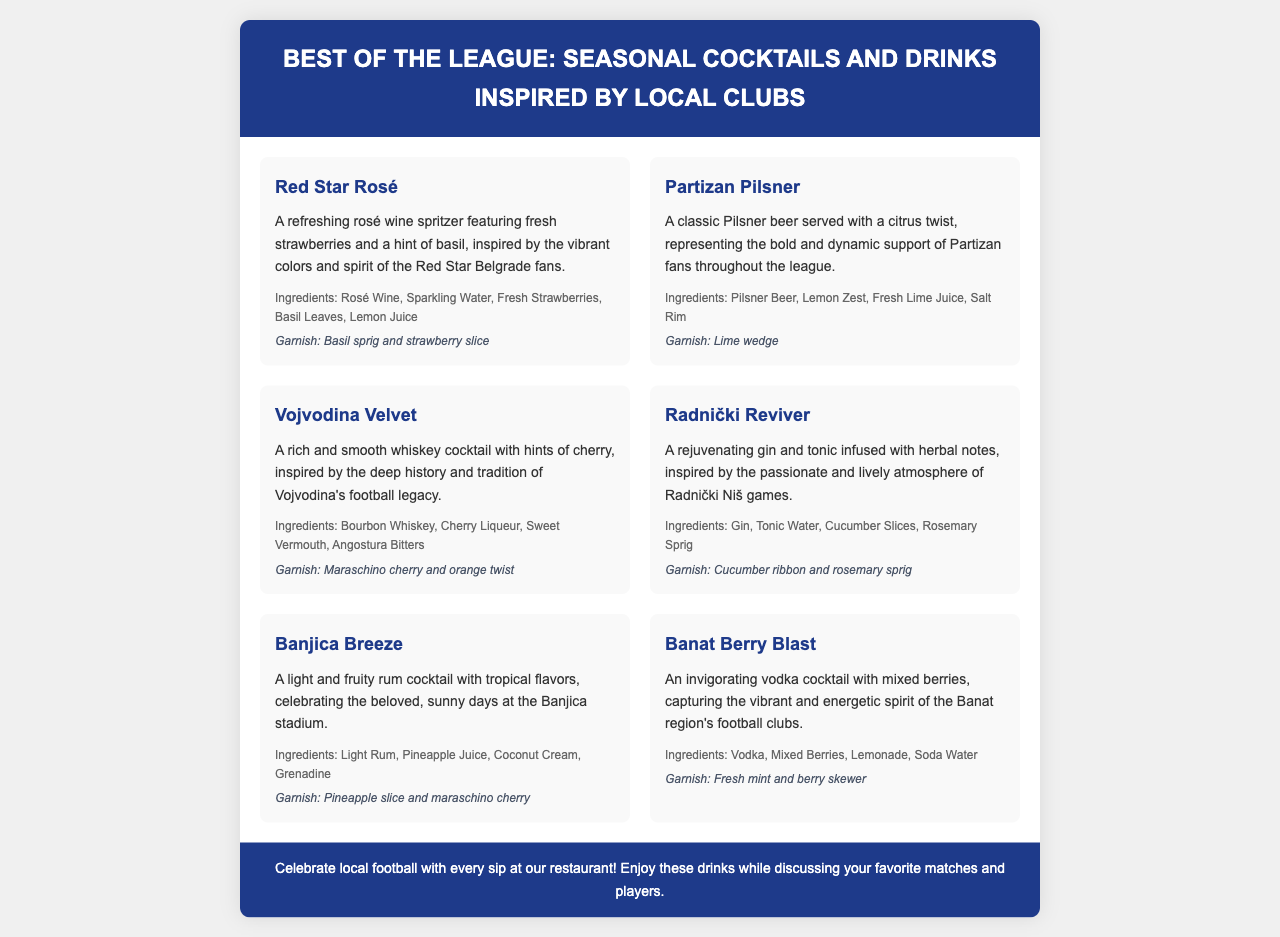What is the first cocktail listed? The first cocktail mentioned in the menu is "Red Star Rosé."
Answer: Red Star Rosé How many cocktails are inspired by local football clubs? There are six cocktails listed in the menu inspired by local football clubs.
Answer: Six What ingredient is found in both the "Radnički Reviver" and "Banjica Breeze"? Both cocktails include fresh cucumber, represented by cucumber slices in "Radnički Reviver" and a cucumber ribbon in "Banjica Breeze."
Answer: Cucumber Which drink features bourbon whiskey? The drink that features bourbon whiskey is "Vojvodina Velvet."
Answer: Vojvodina Velvet What is the garnish for the "Partizan Pilsner"? The garnish for the "Partizan Pilsner" is a lime wedge.
Answer: Lime wedge What type of drink is "Banat Berry Blast"? The "Banat Berry Blast" is a vodka cocktail.
Answer: Vodka cocktail Which cocktail is inspired by the spirit of Red Star Belgrade fans? The cocktail inspired by Red Star Belgrade fans is "Red Star Rosé."
Answer: Red Star Rosé What type of drink is "Banjica Breeze"? The "Banjica Breeze" is a rum cocktail.
Answer: Rum cocktail 